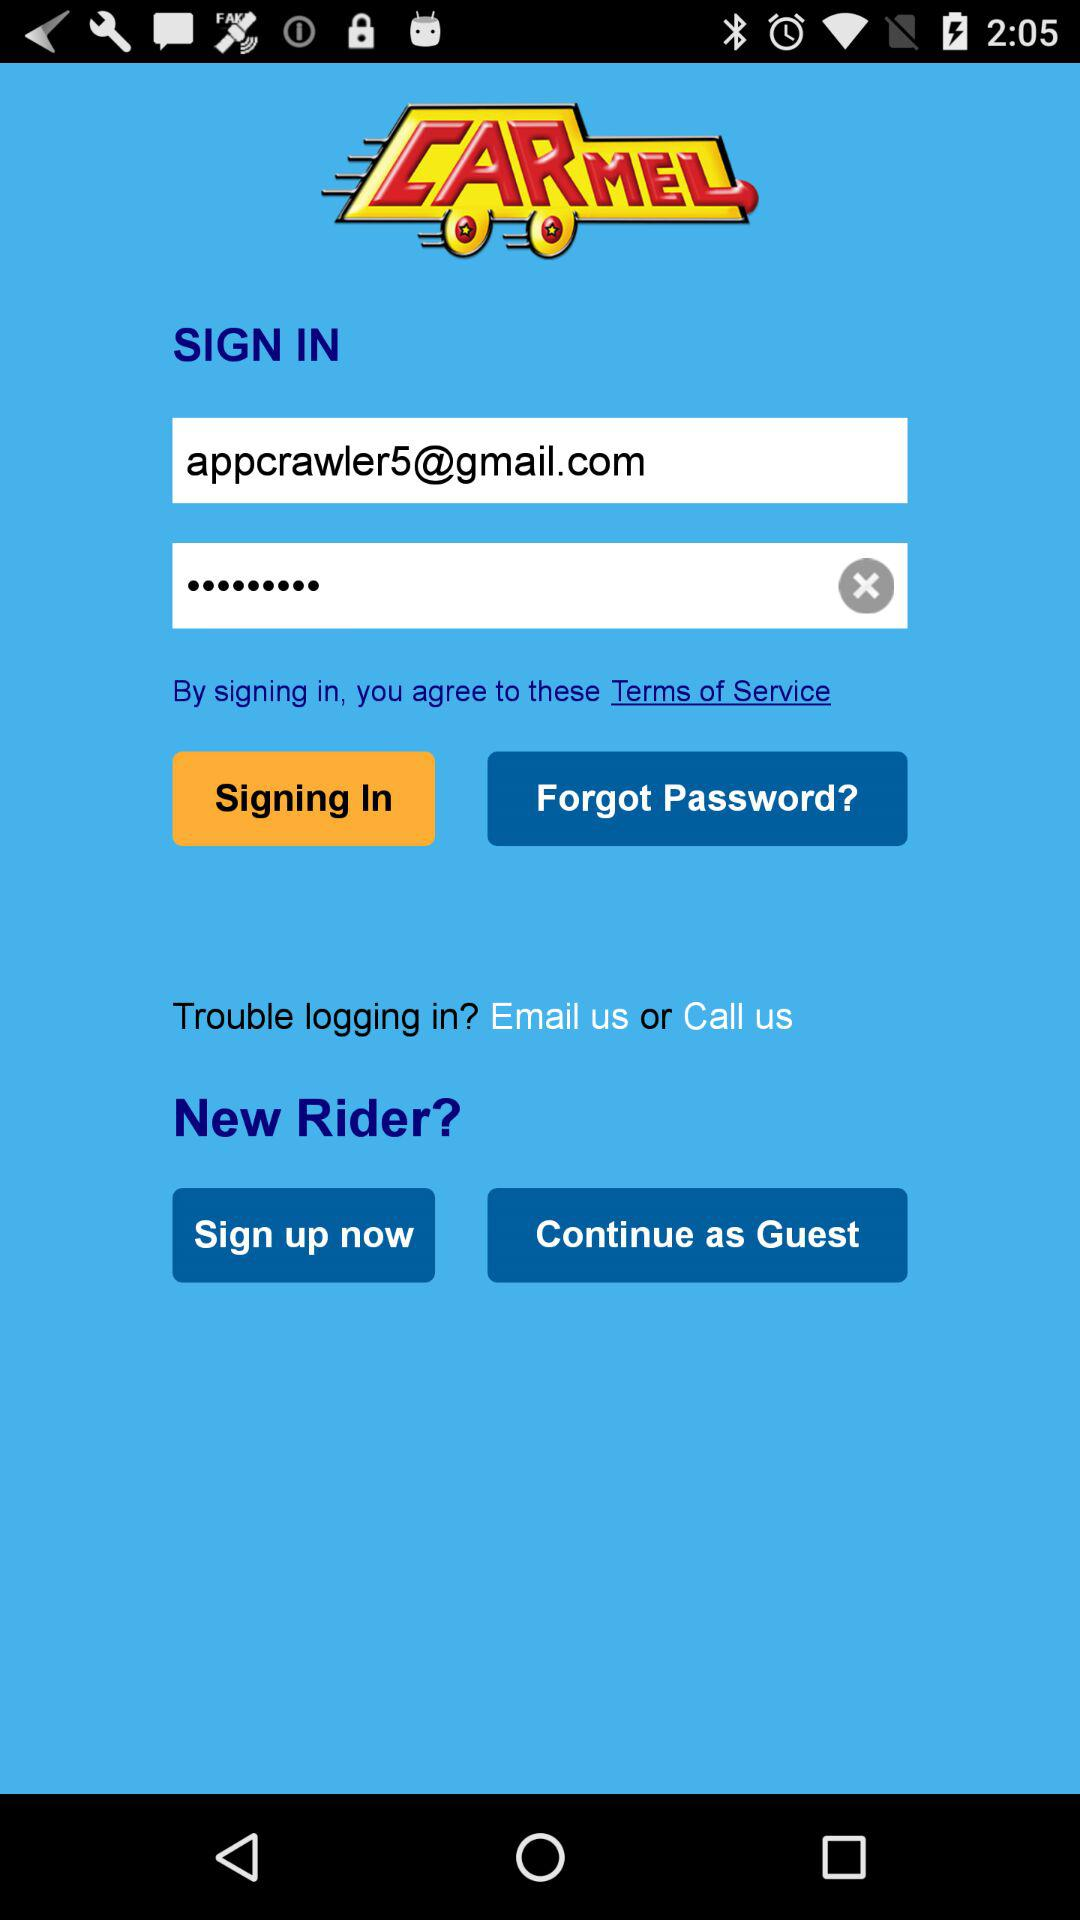How many text inputs are there that do not have a text value?
Answer the question using a single word or phrase. 1 